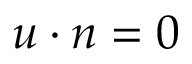<formula> <loc_0><loc_0><loc_500><loc_500>u \cdot n = 0</formula> 